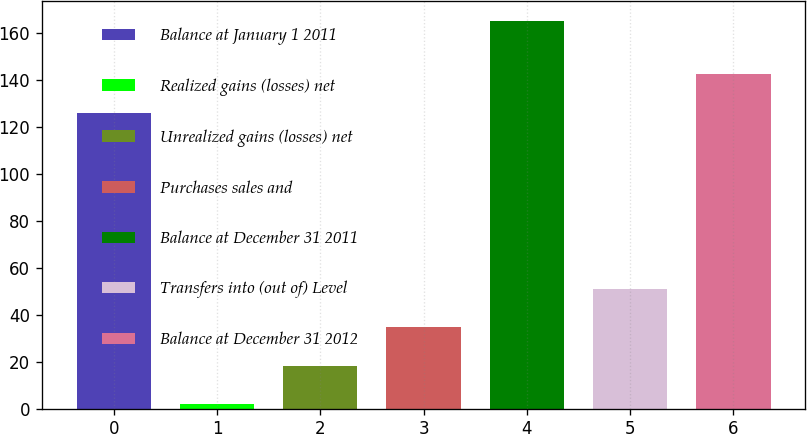Convert chart to OTSL. <chart><loc_0><loc_0><loc_500><loc_500><bar_chart><fcel>Balance at January 1 2011<fcel>Realized gains (losses) net<fcel>Unrealized gains (losses) net<fcel>Purchases sales and<fcel>Balance at December 31 2011<fcel>Transfers into (out of) Level<fcel>Balance at December 31 2012<nl><fcel>126<fcel>2<fcel>18.3<fcel>34.6<fcel>165<fcel>50.9<fcel>142.3<nl></chart> 